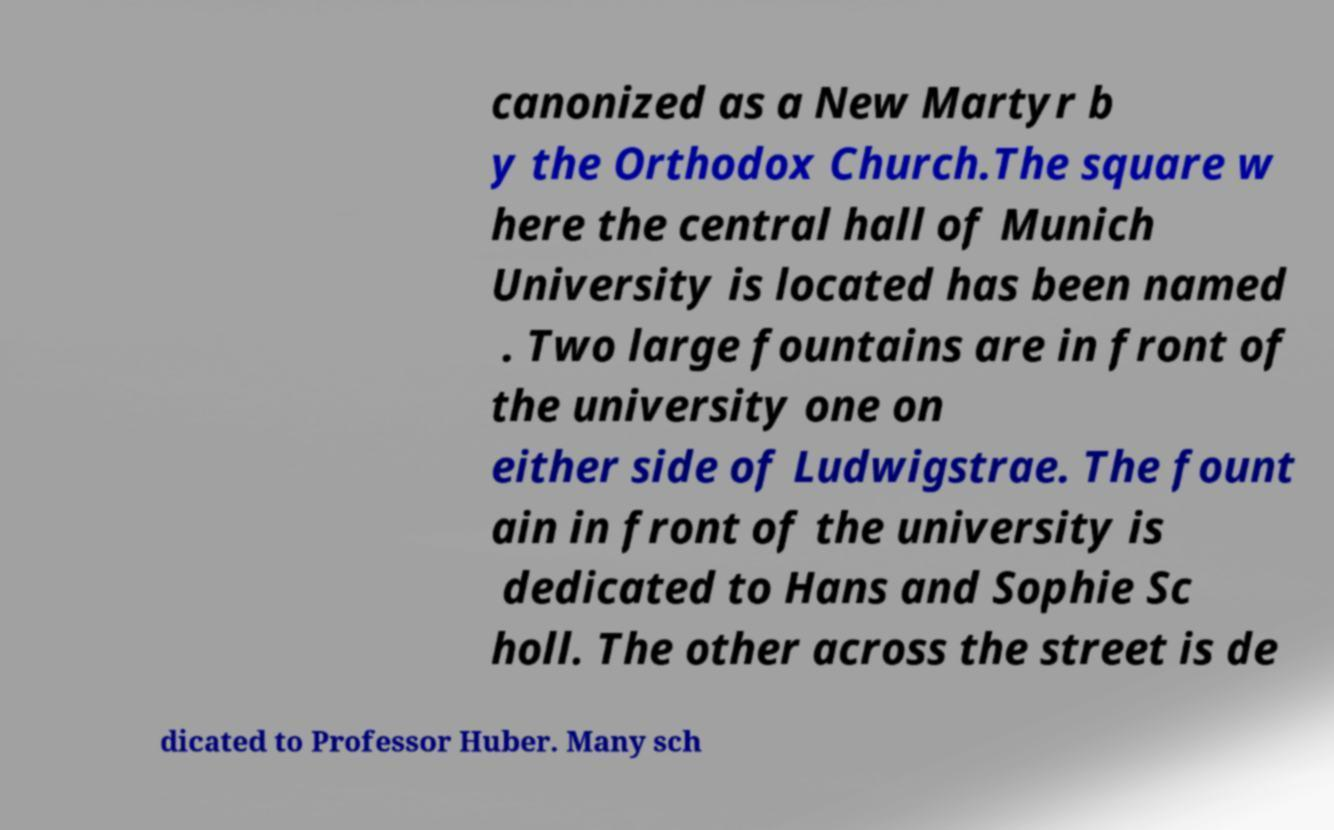For documentation purposes, I need the text within this image transcribed. Could you provide that? canonized as a New Martyr b y the Orthodox Church.The square w here the central hall of Munich University is located has been named . Two large fountains are in front of the university one on either side of Ludwigstrae. The fount ain in front of the university is dedicated to Hans and Sophie Sc holl. The other across the street is de dicated to Professor Huber. Many sch 